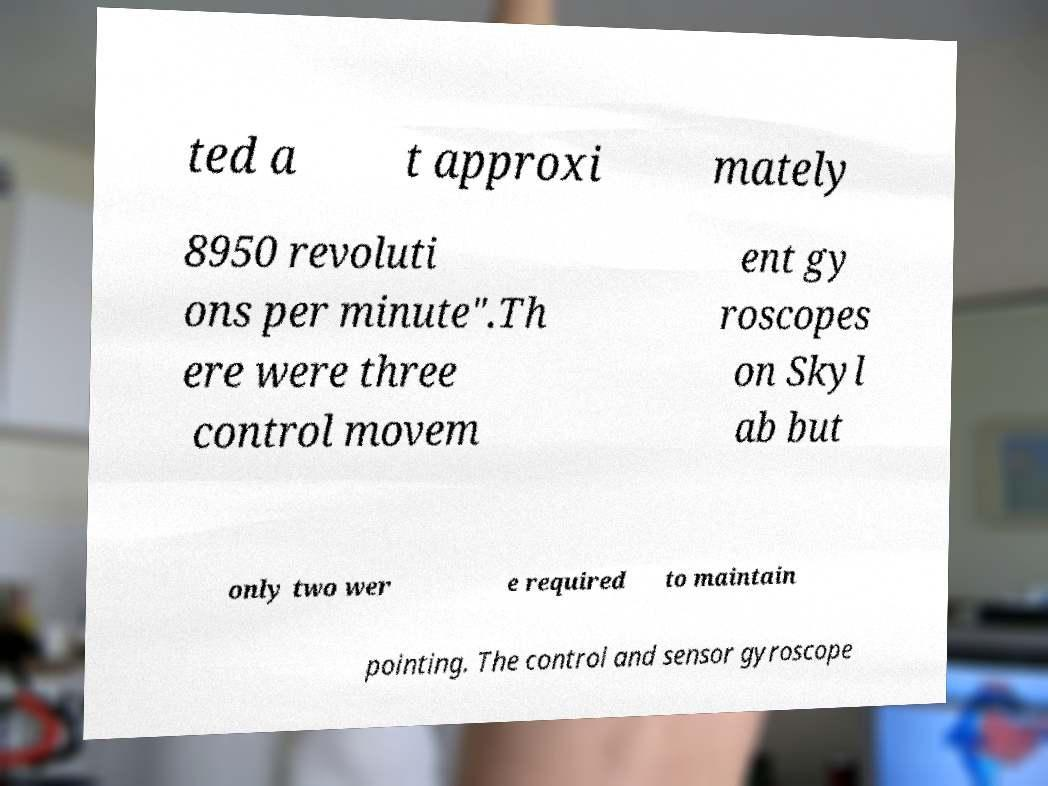What messages or text are displayed in this image? I need them in a readable, typed format. ted a t approxi mately 8950 revoluti ons per minute".Th ere were three control movem ent gy roscopes on Skyl ab but only two wer e required to maintain pointing. The control and sensor gyroscope 